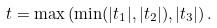Convert formula to latex. <formula><loc_0><loc_0><loc_500><loc_500>t = \max \left ( \min ( | t _ { 1 } | , | t _ { 2 } | ) , | t _ { 3 } | \right ) .</formula> 